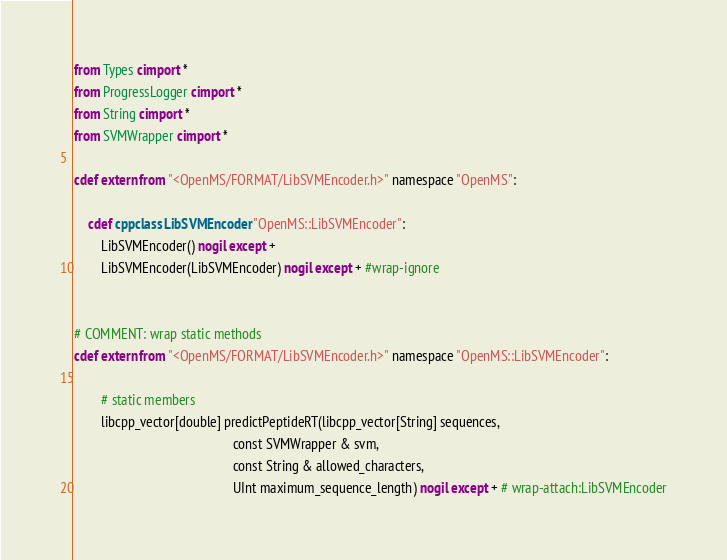Convert code to text. <code><loc_0><loc_0><loc_500><loc_500><_Cython_>from Types cimport *
from ProgressLogger cimport *
from String cimport *
from SVMWrapper cimport *

cdef extern from "<OpenMS/FORMAT/LibSVMEncoder.h>" namespace "OpenMS":
    
    cdef cppclass LibSVMEncoder "OpenMS::LibSVMEncoder":
        LibSVMEncoder() nogil except +
        LibSVMEncoder(LibSVMEncoder) nogil except + #wrap-ignore


# COMMENT: wrap static methods
cdef extern from "<OpenMS/FORMAT/LibSVMEncoder.h>" namespace "OpenMS::LibSVMEncoder":
        
        # static members
        libcpp_vector[double] predictPeptideRT(libcpp_vector[String] sequences,
                                               const SVMWrapper & svm,
                                               const String & allowed_characters,
                                               UInt maximum_sequence_length) nogil except + # wrap-attach:LibSVMEncoder
</code> 